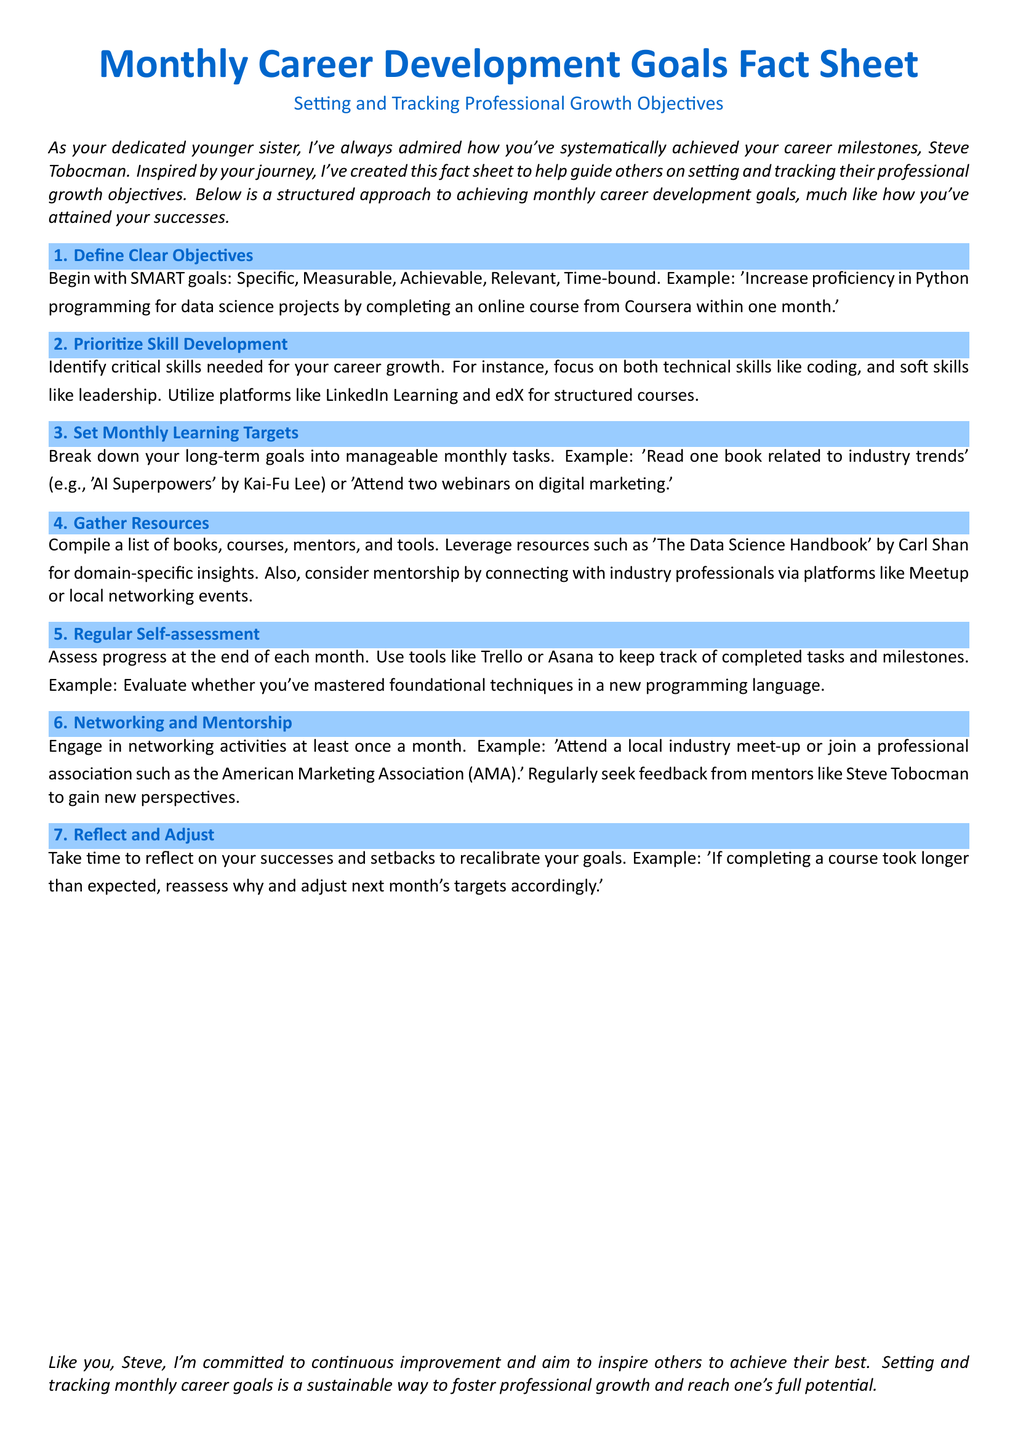What does SMART stand for? SMART goals are defined as Specific, Measurable, Achievable, Relevant, and Time-bound.
Answer: Specific, Measurable, Achievable, Relevant, Time-bound Name one platform mentioned for structured courses. The document suggests utilizing platforms like LinkedIn Learning and edX for structured courses.
Answer: LinkedIn Learning What is the suggested monthly learning target example? An example of a monthly learning target is 'Read one book related to industry trends.'
Answer: Read one book What tool is recommended for self-assessment? Tools like Trello or Asana are recommended to keep track of completed tasks and milestones.
Answer: Trello What should you do at least once a month according to the document? The document mentions engaging in networking activities at least once a month.
Answer: Networking activities What is the purpose of reflecting and adjusting your goals? Reflecting on successes and setbacks helps to recalibrate your goals.
Answer: Recalibrate goals What type of skills should be prioritized for development? Critical skills include both technical skills like coding and soft skills like leadership.
Answer: Technical and soft skills What is a suggested resource for domain-specific insights? 'The Data Science Handbook' by Carl Shan is suggested for domain-specific insights.
Answer: The Data Science Handbook What organization is mentioned for professional associations? The American Marketing Association (AMA) is mentioned for networking opportunities.
Answer: American Marketing Association 